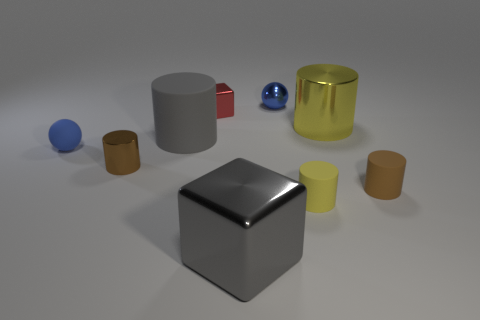Subtract all big gray cylinders. How many cylinders are left? 4 Subtract all gray cylinders. How many cylinders are left? 4 Subtract all red cylinders. Subtract all green balls. How many cylinders are left? 5 Add 1 small matte cylinders. How many objects exist? 10 Subtract all balls. How many objects are left? 7 Subtract 0 purple balls. How many objects are left? 9 Subtract all shiny blocks. Subtract all green shiny cylinders. How many objects are left? 7 Add 2 tiny rubber cylinders. How many tiny rubber cylinders are left? 4 Add 6 large yellow metallic objects. How many large yellow metallic objects exist? 7 